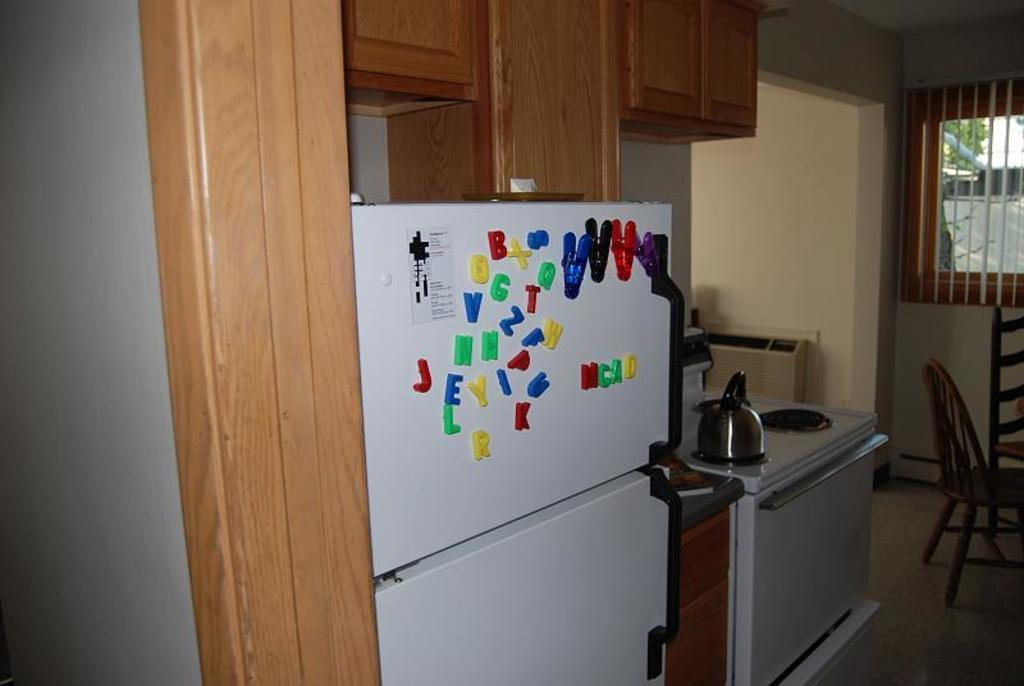Provide a one-sentence caption for the provided image. A refrigerator with alphabetical magnets on display in a standard kitchen. 